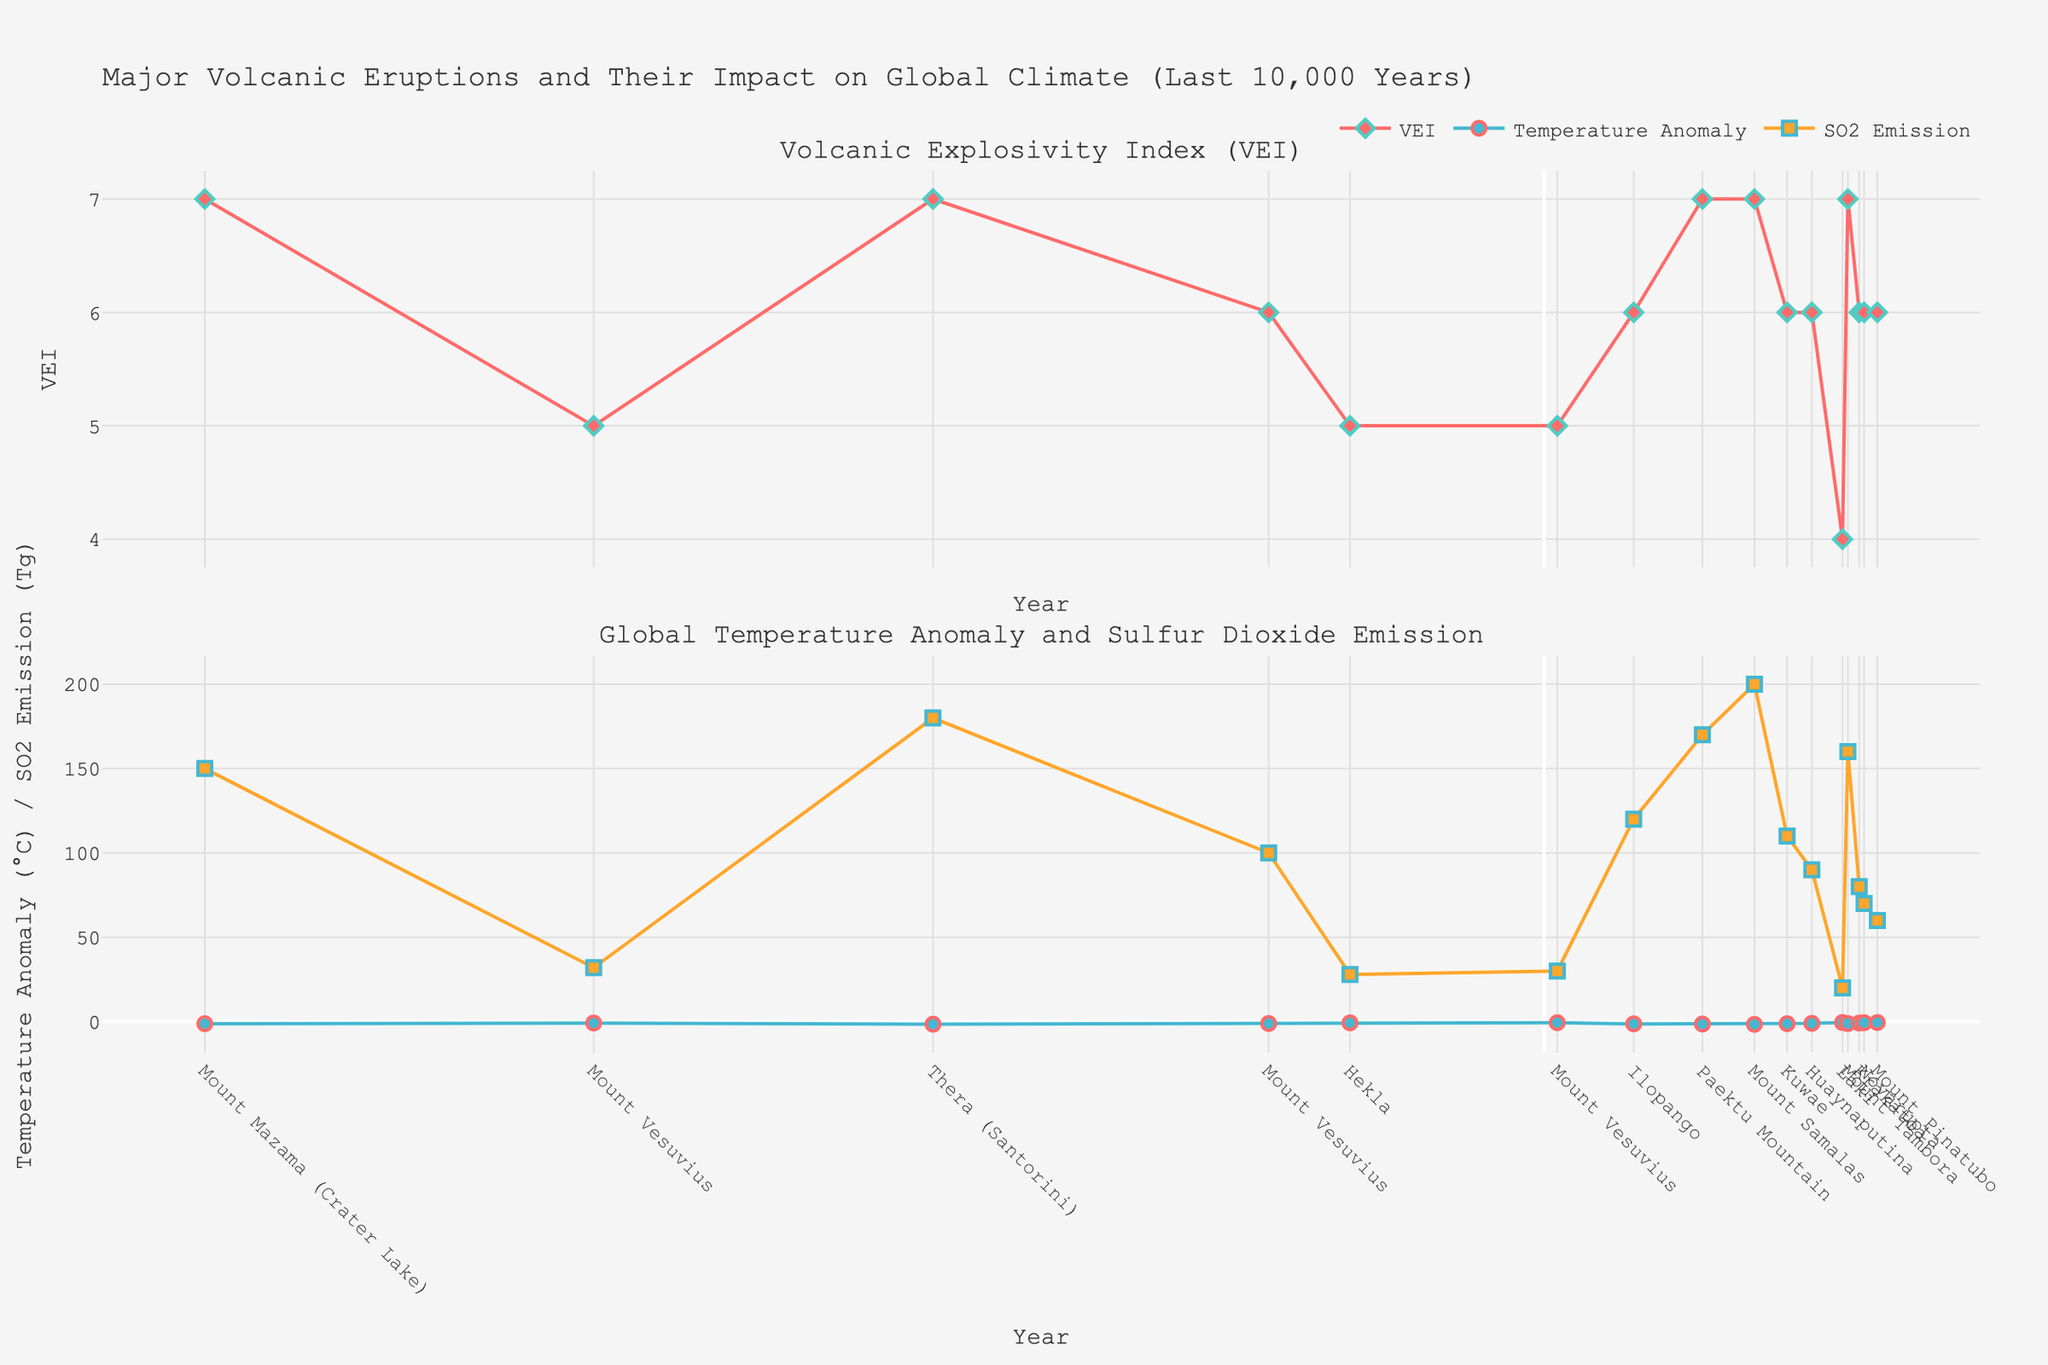what is the highest Volcanic Explosivity Index (VEI) recorded and in which year did it occur? The highest VEI record in the chart is detected by looking for the tallest point in the upper plot. The highest VEI is 7, which happened multiple times: in 8000 BCE (Mount Mazama), 3650 BCE (Thera), 946 CE (Paektu Mountain), and 1257 CE (Mount Samalas).
Answer: VEI 7 in 8000 BCE, 3650 BCE, 946 CE, and 1257 CE What was the global temperature anomaly in 1257 CE compared to 1815 CE? To find this, check the points representing the global temperature anomaly for both years in the lower plot. The anomaly in 1257 CE is -1.6°C, and in 1815 CE it is -1.1°C. The anomaly in 1257 CE was 0.5°C more negative than in 1815 CE.
Answer: -1.6°C in 1257 CE, -1.1°C in 1815 CE Which eruption had the highest Sulfur Dioxide Emission and what was the corresponding global temperature anomaly? The eruption with the highest SO2 emission can be found by identifying the tallest point in the lower plot (SO2 trace). The highest SO2 emissions were recorded for Mount Samalas (1257 CE) with 200 Tg. The corresponding global temperature anomaly is -1.6°C.
Answer: Mount Samalas (200 Tg), -1.6°C How many eruptions had a VEI of 6, and what was their average global temperature anomaly? First, identify the eruptions with a VEI of 6 in the upper plot and count them. There are 6 such eruptions (1645 BCE, 536 CE, 1452 CE, 1600 CE, 1883 CE, and 1912 CE). Then, find the temperature anomalies for these years and compute their average: (-1.1) + (-1.3) + (-1.2) + (-1.0) + (-0.8) + (-0.6) = -6.0, average is -6.0 / 6 = -1.0.
Answer: 6 eruptions, -1.0°C average anomaly Between 1645 BCE and 79 CE which eruption had a greater impact on global temperature anomaly? Look at the points for these years in the lower plot. The 1645 BCE (Mount Vesuvius) anomaly is -1.1°C, and the 79 CE (Mount Vesuvius) anomaly is -0.6°C. The 1645 BCE eruption had a greater impact on temperature anomaly.
Answer: 1645 BCE (-1.1°C) had a greater impact What is the time interval between the eruption of Mount Tambora and Krakatoa, and how did their Sulfur Dioxide Emissions compare? Calculate the years between 1815 CE (Mount Tambora) and 1883 CE (Krakatoa): 1883 - 1815 = 68 years. Compare their SO2 emissions: Mount Tambora (160 Tg) emitted more than Krakatoa (80 Tg).
Answer: 68 years, Tambora emitted more (160 Tg vs 80 Tg) Which eruption marked the beginning of a significant global temperature anomaly decrease in the 6th century CE? Check the lower plot around the 6th century. The anomaly significantly decreased around 536 CE (Ilopango) with a -1.3°C drop.
Answer: Ilopango (536 CE) Is there a positive correlation between Sulfur Dioxide Emissions and global temperature anomaly magnitude? Observe the lower plot for SO2 emissions and temperature anomalies. Generally, higher SO2 emissions correspond to more negative (lower) temperature anomalies, indicating a negative correlation.
Answer: Negative correlation 